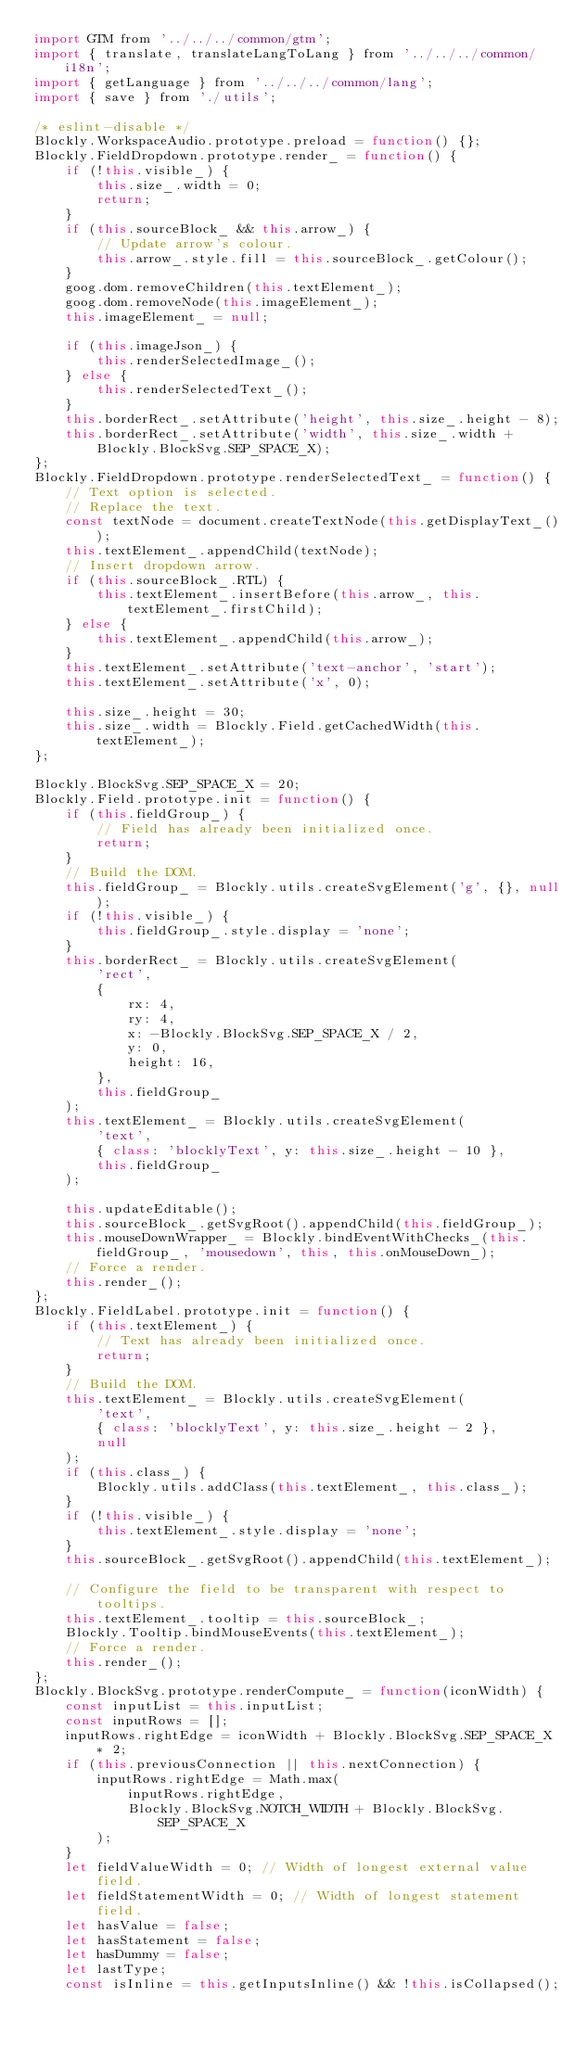Convert code to text. <code><loc_0><loc_0><loc_500><loc_500><_JavaScript_>import GTM from '../../../common/gtm';
import { translate, translateLangToLang } from '../../../common/i18n';
import { getLanguage } from '../../../common/lang';
import { save } from './utils';

/* eslint-disable */
Blockly.WorkspaceAudio.prototype.preload = function() {};
Blockly.FieldDropdown.prototype.render_ = function() {
    if (!this.visible_) {
        this.size_.width = 0;
        return;
    }
    if (this.sourceBlock_ && this.arrow_) {
        // Update arrow's colour.
        this.arrow_.style.fill = this.sourceBlock_.getColour();
    }
    goog.dom.removeChildren(this.textElement_);
    goog.dom.removeNode(this.imageElement_);
    this.imageElement_ = null;

    if (this.imageJson_) {
        this.renderSelectedImage_();
    } else {
        this.renderSelectedText_();
    }
    this.borderRect_.setAttribute('height', this.size_.height - 8);
    this.borderRect_.setAttribute('width', this.size_.width + Blockly.BlockSvg.SEP_SPACE_X);
};
Blockly.FieldDropdown.prototype.renderSelectedText_ = function() {
    // Text option is selected.
    // Replace the text.
    const textNode = document.createTextNode(this.getDisplayText_());
    this.textElement_.appendChild(textNode);
    // Insert dropdown arrow.
    if (this.sourceBlock_.RTL) {
        this.textElement_.insertBefore(this.arrow_, this.textElement_.firstChild);
    } else {
        this.textElement_.appendChild(this.arrow_);
    }
    this.textElement_.setAttribute('text-anchor', 'start');
    this.textElement_.setAttribute('x', 0);

    this.size_.height = 30;
    this.size_.width = Blockly.Field.getCachedWidth(this.textElement_);
};

Blockly.BlockSvg.SEP_SPACE_X = 20;
Blockly.Field.prototype.init = function() {
    if (this.fieldGroup_) {
        // Field has already been initialized once.
        return;
    }
    // Build the DOM.
    this.fieldGroup_ = Blockly.utils.createSvgElement('g', {}, null);
    if (!this.visible_) {
        this.fieldGroup_.style.display = 'none';
    }
    this.borderRect_ = Blockly.utils.createSvgElement(
        'rect',
        {
            rx: 4,
            ry: 4,
            x: -Blockly.BlockSvg.SEP_SPACE_X / 2,
            y: 0,
            height: 16,
        },
        this.fieldGroup_
    );
    this.textElement_ = Blockly.utils.createSvgElement(
        'text',
        { class: 'blocklyText', y: this.size_.height - 10 },
        this.fieldGroup_
    );

    this.updateEditable();
    this.sourceBlock_.getSvgRoot().appendChild(this.fieldGroup_);
    this.mouseDownWrapper_ = Blockly.bindEventWithChecks_(this.fieldGroup_, 'mousedown', this, this.onMouseDown_);
    // Force a render.
    this.render_();
};
Blockly.FieldLabel.prototype.init = function() {
    if (this.textElement_) {
        // Text has already been initialized once.
        return;
    }
    // Build the DOM.
    this.textElement_ = Blockly.utils.createSvgElement(
        'text',
        { class: 'blocklyText', y: this.size_.height - 2 },
        null
    );
    if (this.class_) {
        Blockly.utils.addClass(this.textElement_, this.class_);
    }
    if (!this.visible_) {
        this.textElement_.style.display = 'none';
    }
    this.sourceBlock_.getSvgRoot().appendChild(this.textElement_);

    // Configure the field to be transparent with respect to tooltips.
    this.textElement_.tooltip = this.sourceBlock_;
    Blockly.Tooltip.bindMouseEvents(this.textElement_);
    // Force a render.
    this.render_();
};
Blockly.BlockSvg.prototype.renderCompute_ = function(iconWidth) {
    const inputList = this.inputList;
    const inputRows = [];
    inputRows.rightEdge = iconWidth + Blockly.BlockSvg.SEP_SPACE_X * 2;
    if (this.previousConnection || this.nextConnection) {
        inputRows.rightEdge = Math.max(
            inputRows.rightEdge,
            Blockly.BlockSvg.NOTCH_WIDTH + Blockly.BlockSvg.SEP_SPACE_X
        );
    }
    let fieldValueWidth = 0; // Width of longest external value field.
    let fieldStatementWidth = 0; // Width of longest statement field.
    let hasValue = false;
    let hasStatement = false;
    let hasDummy = false;
    let lastType;
    const isInline = this.getInputsInline() && !this.isCollapsed();</code> 